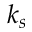<formula> <loc_0><loc_0><loc_500><loc_500>k _ { s }</formula> 